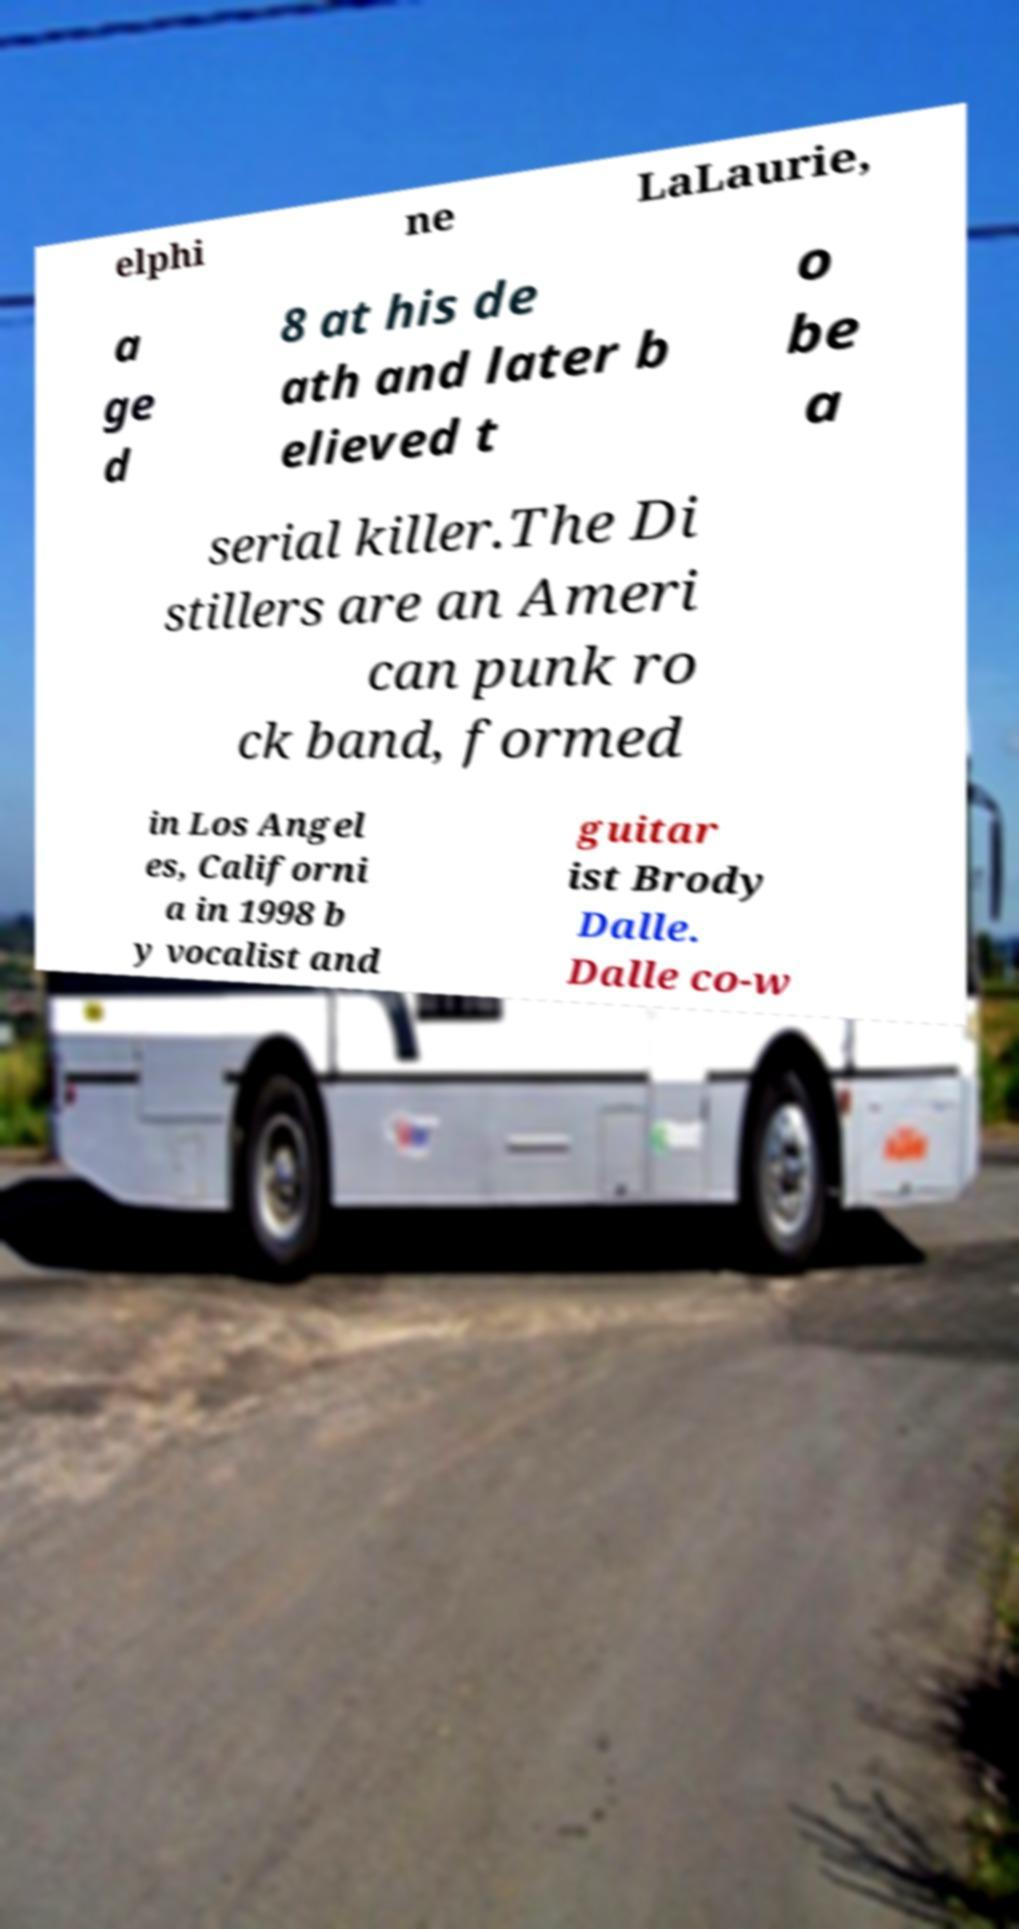Could you extract and type out the text from this image? elphi ne LaLaurie, a ge d 8 at his de ath and later b elieved t o be a serial killer.The Di stillers are an Ameri can punk ro ck band, formed in Los Angel es, Californi a in 1998 b y vocalist and guitar ist Brody Dalle. Dalle co-w 